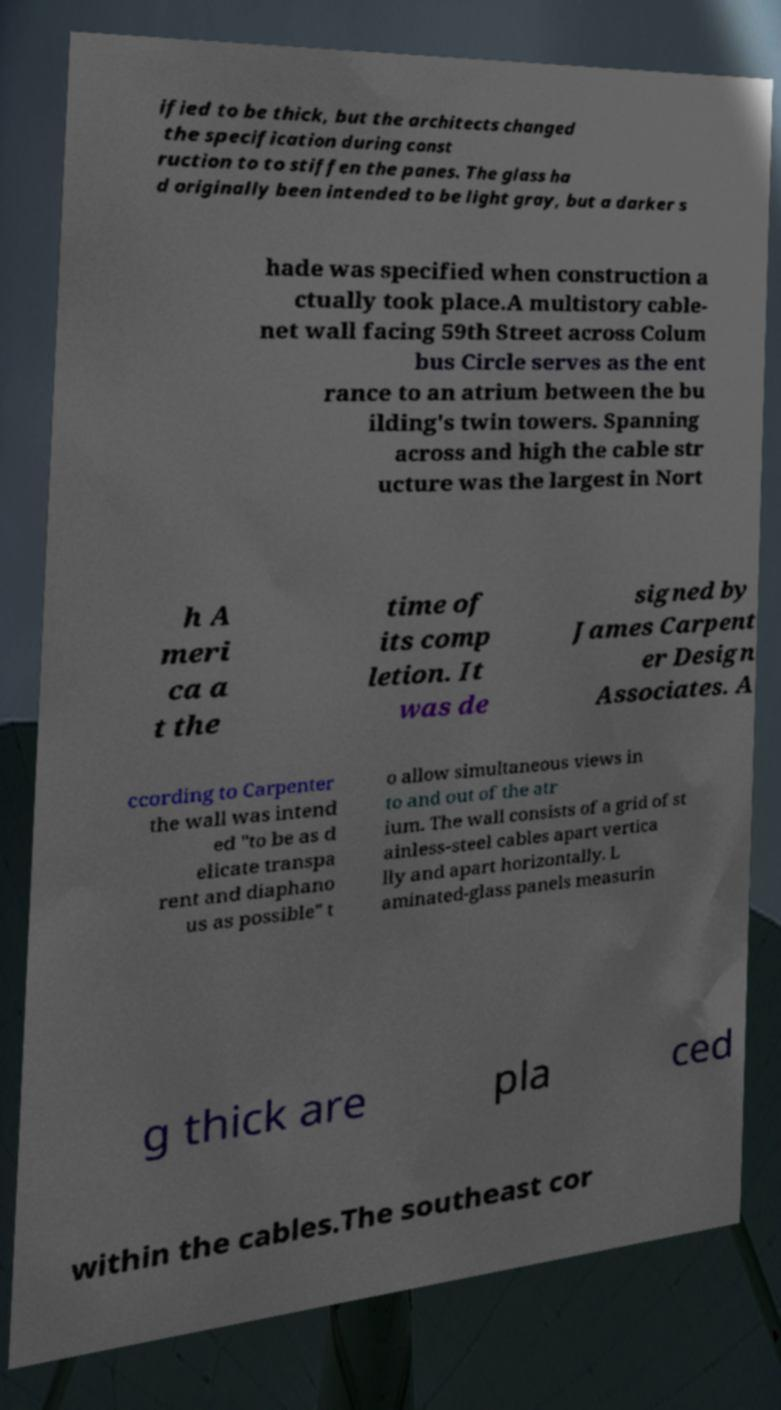Can you read and provide the text displayed in the image?This photo seems to have some interesting text. Can you extract and type it out for me? ified to be thick, but the architects changed the specification during const ruction to to stiffen the panes. The glass ha d originally been intended to be light gray, but a darker s hade was specified when construction a ctually took place.A multistory cable- net wall facing 59th Street across Colum bus Circle serves as the ent rance to an atrium between the bu ilding's twin towers. Spanning across and high the cable str ucture was the largest in Nort h A meri ca a t the time of its comp letion. It was de signed by James Carpent er Design Associates. A ccording to Carpenter the wall was intend ed "to be as d elicate transpa rent and diaphano us as possible" t o allow simultaneous views in to and out of the atr ium. The wall consists of a grid of st ainless-steel cables apart vertica lly and apart horizontally. L aminated-glass panels measurin g thick are pla ced within the cables.The southeast cor 